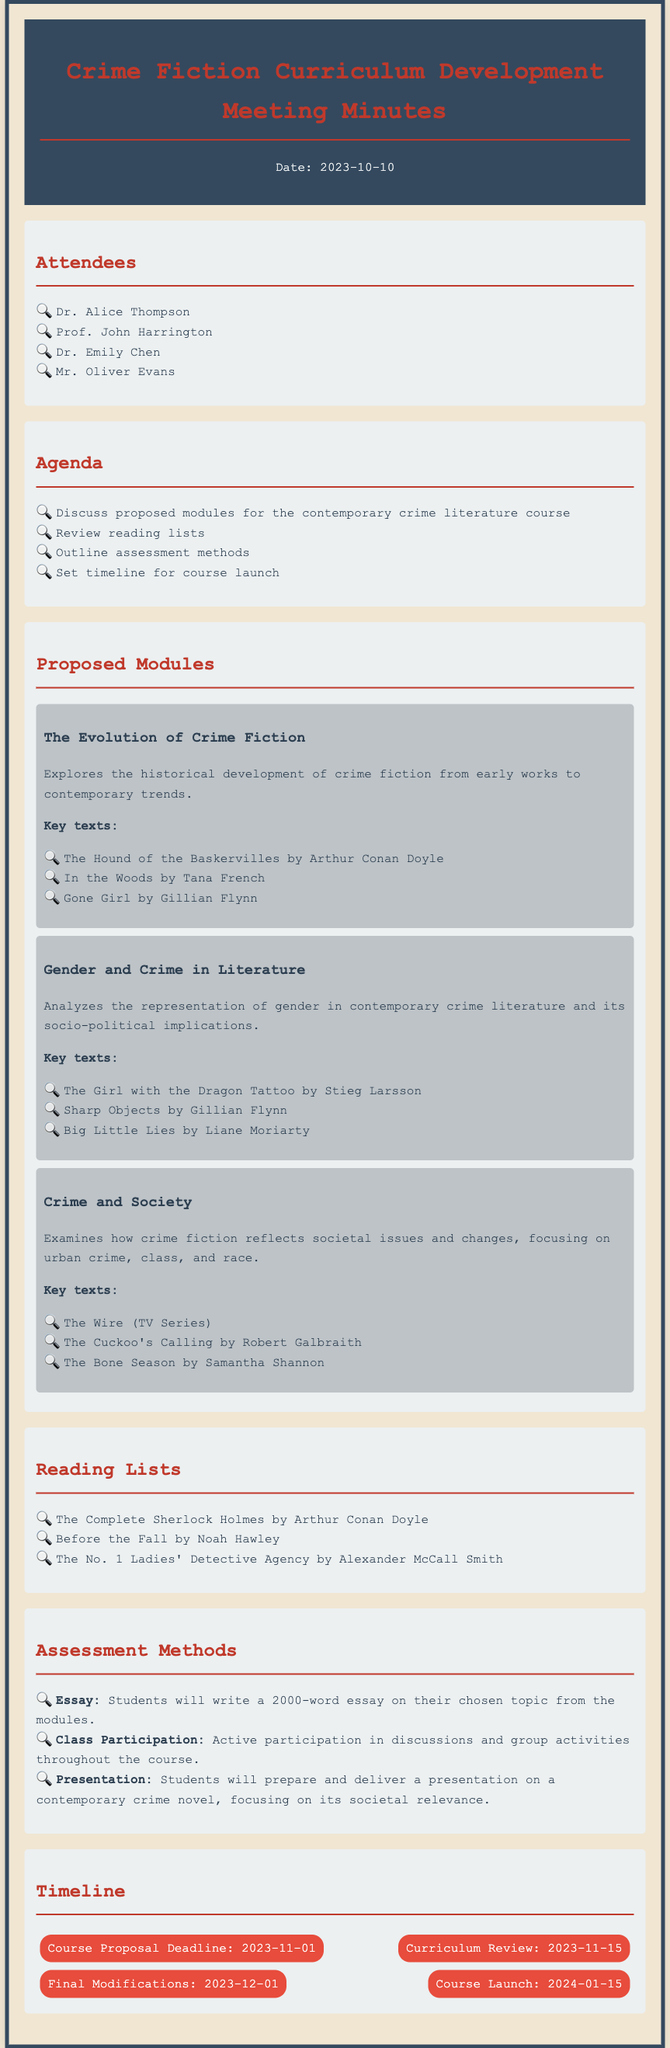What is the date of the meeting? The date is specifically mentioned at the beginning of the document, under the header.
Answer: 2023-10-10 Who is one of the attendees? The attendees are listed in a bullet format, and any name can be taken as a valid answer.
Answer: Dr. Alice Thompson What is one of the proposed modules? The proposed modules section lists specific titles for each module, which can be referenced directly.
Answer: The Evolution of Crime Fiction What are the key texts for one of the modules? Each module includes a section outlining key texts that are relevant to that module.
Answer: The Hound of the Baskervilles by Arthur Conan Doyle What type of assessment will be used? The assessment methods section outlines different ways students will be evaluated.
Answer: Essay When is the course launch date? The timeline clearly specifies the date for the course launch under a specific heading.
Answer: 2024-01-15 How many words should the essay be? The assessment methods describe the length requirement for the essay.
Answer: 2000-word What is the focus of the module "Gender and Crime in Literature"? The description under the module details the specific focus or theme of the coursework.
Answer: Representation of gender What is the timeline item for curriculum review? The timeline section lists specific milestones and their corresponding dates.
Answer: 2023-11-15 What key text is listed under "Crime and Society"? The module names different texts considered important for that module, one of which can be selected.
Answer: The Wire (TV Series) 